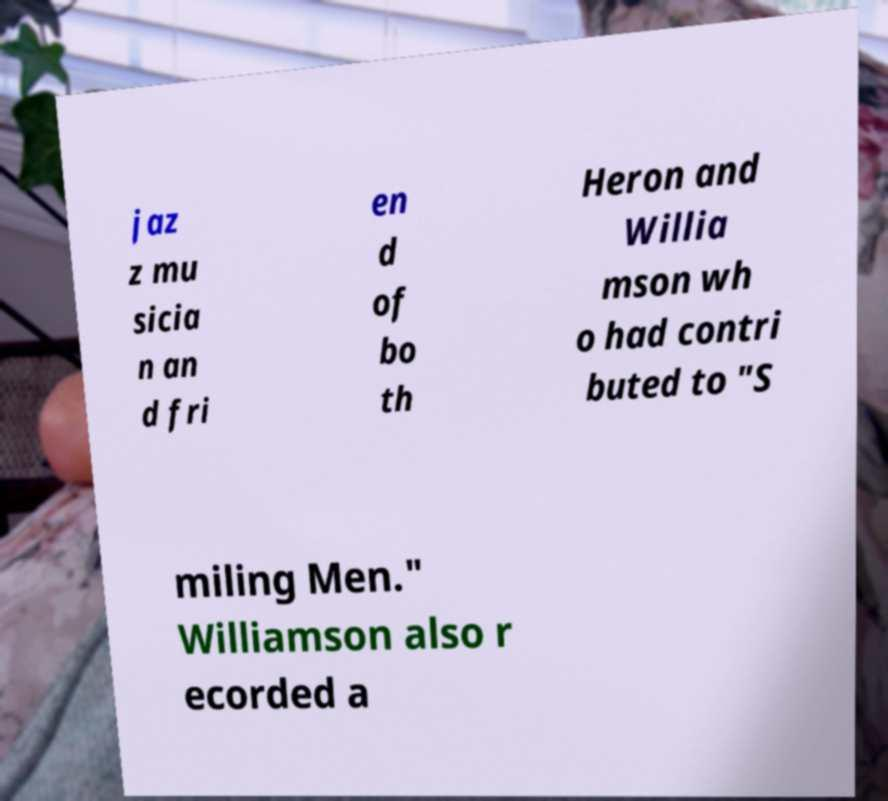There's text embedded in this image that I need extracted. Can you transcribe it verbatim? jaz z mu sicia n an d fri en d of bo th Heron and Willia mson wh o had contri buted to "S miling Men." Williamson also r ecorded a 